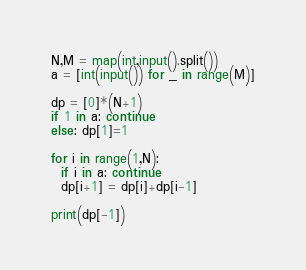<code> <loc_0><loc_0><loc_500><loc_500><_Python_>N,M = map(int,input().split())
a = [int(input()) for _ in range(M)]

dp = [0]*(N+1)
if 1 in a: continue
else: dp[1]=1

for i in range(1,N):
  if i in a: continue
  dp[i+1] = dp[i]+dp[i-1]
  
print(dp[-1])</code> 